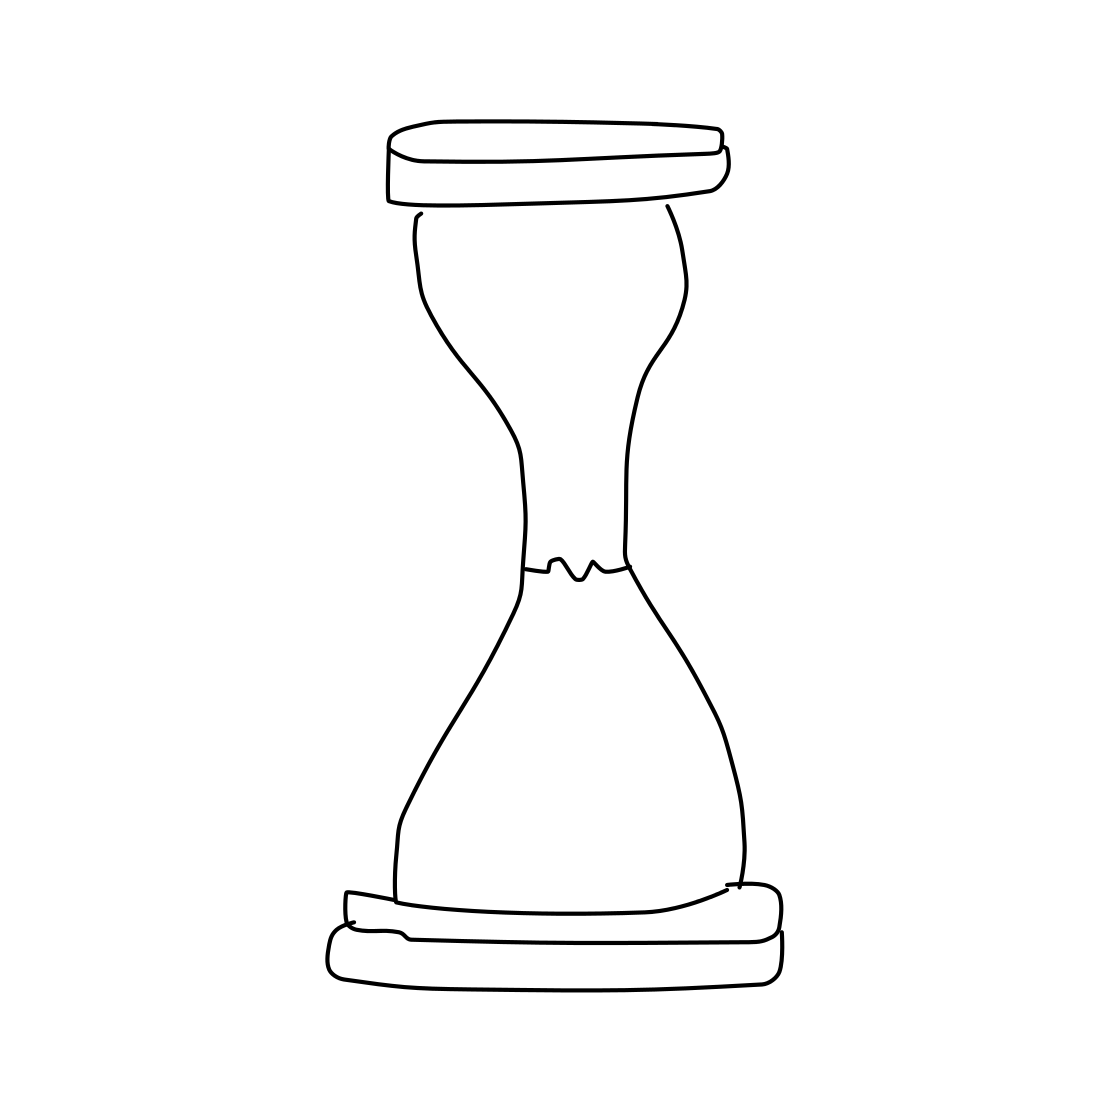Is there a sketchy hourglass in the picture? Absolutely, the image features a line drawing of an hourglass with a classic design, consisting of two conical containers connected at the midpoint, ostensibly for the purpose of measuring the passage of time. 